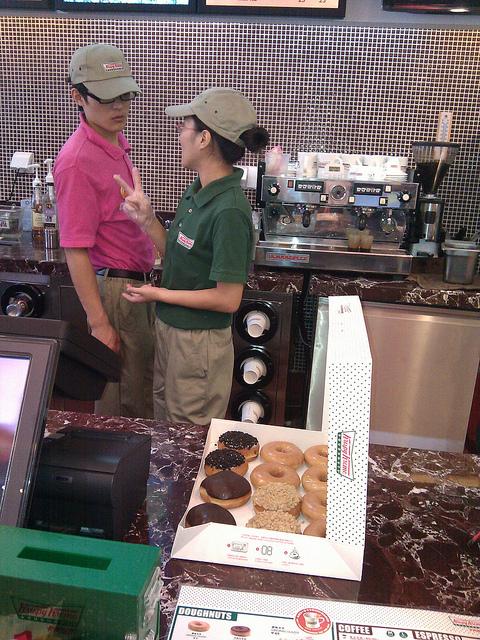How many people are in the photo?
Answer briefly. 2. What food is shown?
Be succinct. Donuts. What pattern is on the wall?
Be succinct. Checkers. 